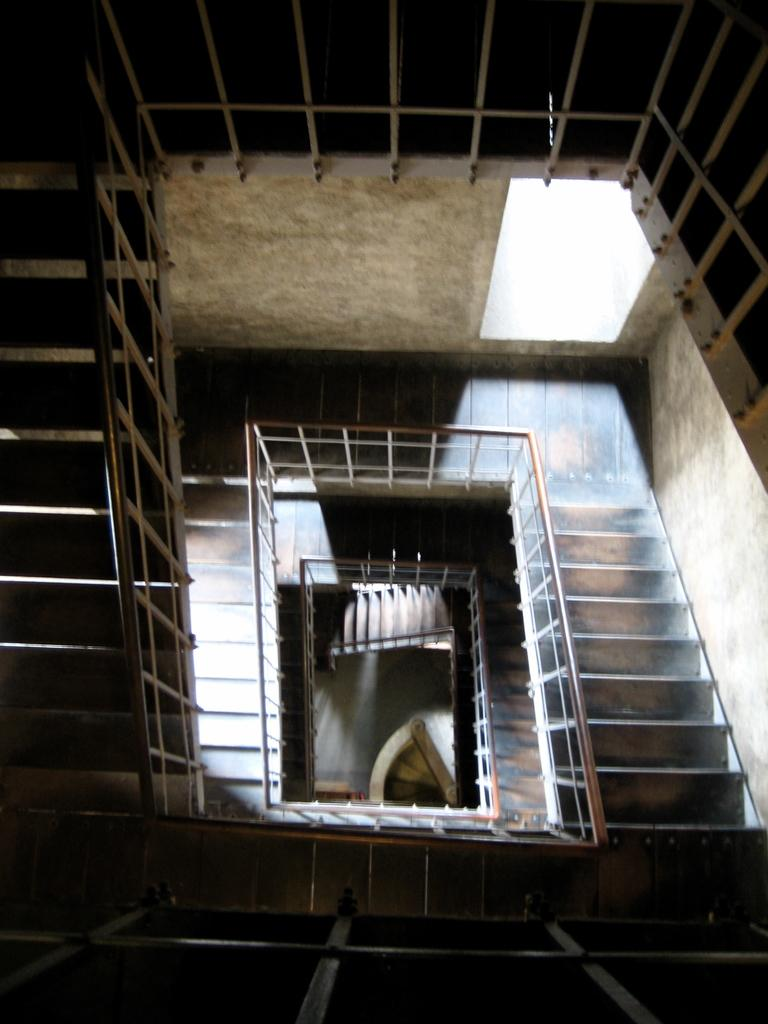What type of structure can be seen in the image? There are stairs, railing, and a wall visible in the image. What might be used for support or safety while using the stairs? The railing in the image can be used for support or safety while using the stairs. What is the purpose of the wall in the image? The wall in the image might provide support, separation, or protection. How much wealth is represented by the nose in the image? There is no nose present in the image, and therefore no wealth can be associated with it. 